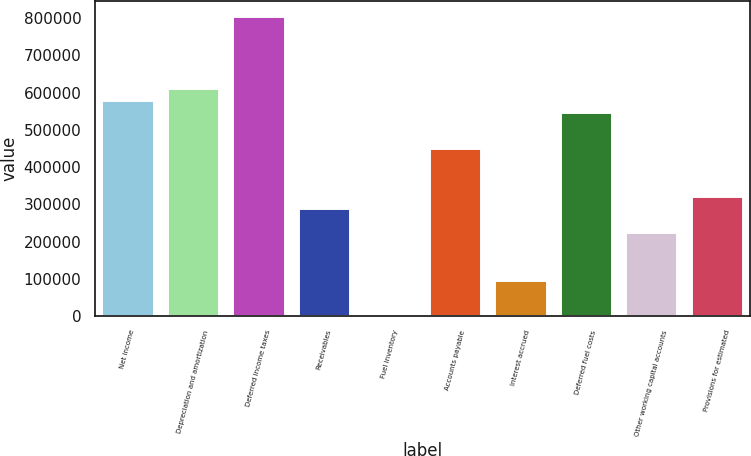<chart> <loc_0><loc_0><loc_500><loc_500><bar_chart><fcel>Net income<fcel>Depreciation and amortization<fcel>Deferred income taxes<fcel>Receivables<fcel>Fuel inventory<fcel>Accounts payable<fcel>Interest accrued<fcel>Deferred fuel costs<fcel>Other working capital accounts<fcel>Provisions for estimated<nl><fcel>580769<fcel>613030<fcel>806596<fcel>290420<fcel>71<fcel>451725<fcel>96854<fcel>548508<fcel>225898<fcel>322681<nl></chart> 